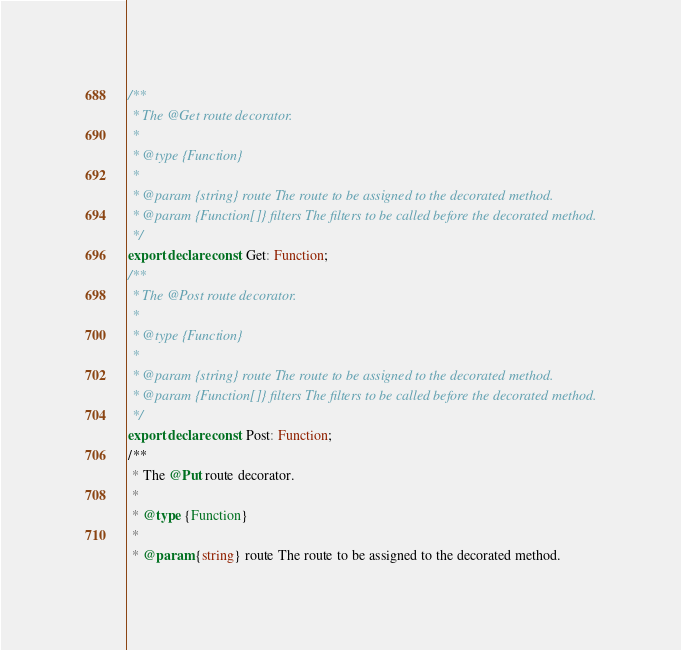Convert code to text. <code><loc_0><loc_0><loc_500><loc_500><_TypeScript_>/**
 * The @Get route decorator.
 *
 * @type {Function}
 *
 * @param {string} route The route to be assigned to the decorated method.
 * @param {Function[]} filters The filters to be called before the decorated method.
 */
export declare const Get: Function;
/**
 * The @Post route decorator.
 *
 * @type {Function}
 *
 * @param {string} route The route to be assigned to the decorated method.
 * @param {Function[]} filters The filters to be called before the decorated method.
 */
export declare const Post: Function;
/**
 * The @Put route decorator.
 *
 * @type {Function}
 *
 * @param {string} route The route to be assigned to the decorated method.</code> 